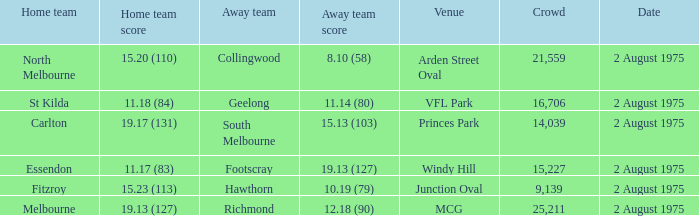How many people attended the game at VFL Park? 16706.0. 